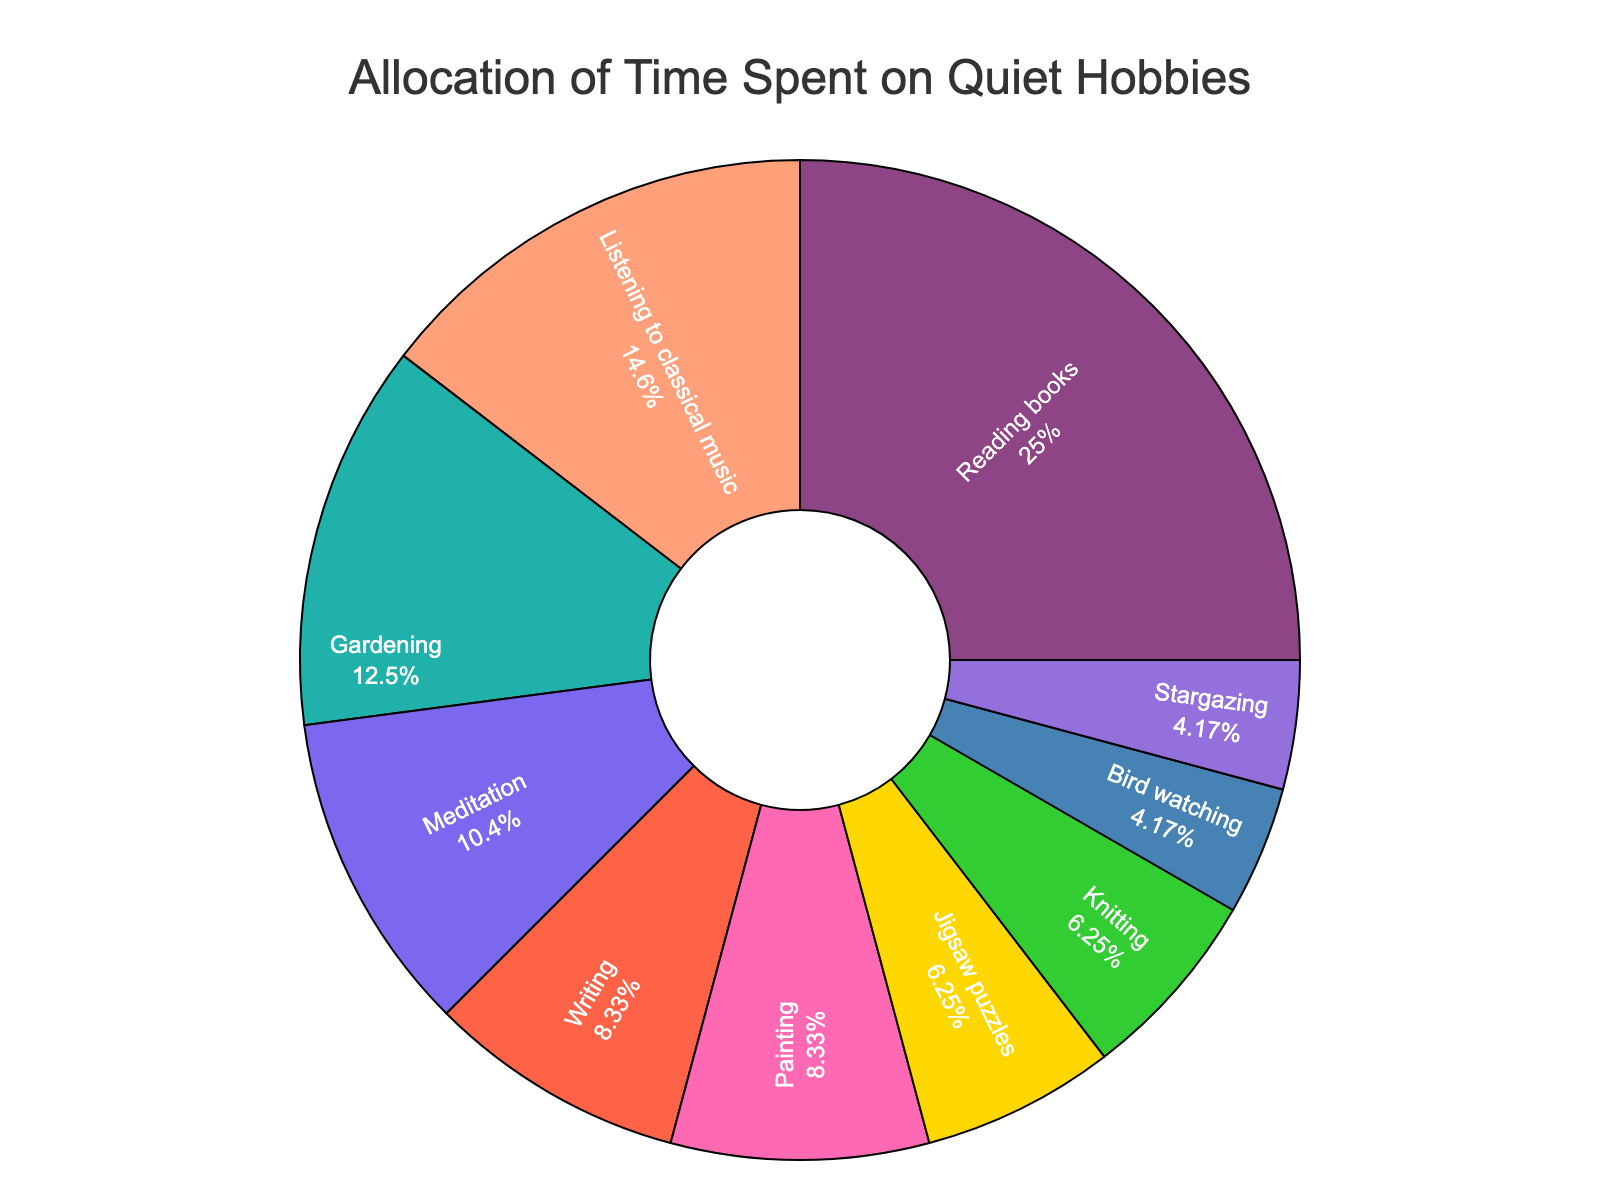What's the total amount of time spent on hobbies per week? The total amount of time is provided as an annotation below the pie chart. It states "Total: 48 hours per week."
Answer: 48 hours Which hobby takes up the most time? By looking at the pie chart segments, the largest section is labeled "Reading books" with 12 hours per week.
Answer: Reading books What percentage of the total time is spent on listening to classical music? According to the chart, "Listening to classical music" occupies a segment labeled with 7 hours. The percentage is also displayed as a value for each segment.
Answer: ~14.58% How much more time is spent on gardening compared to writing? The pie chart shows 6 hours for Gardening and 4 hours for Writing. Subtract the smaller value from the larger one: 6 - 4.
Answer: 2 hours Which hobby occupies the smallest portion of the chart? The smallest segment corresponds to "Bird watching" and "Stargazing" each with 2 hours.
Answer: Bird watching and Stargazing How many hours per week are spent on hobbies other than reading books? Subtract the hours spent on "Reading books" from the total hours: 48 - 12.
Answer: 36 hours Is the time spent on meditation greater than the time spent on painting? According to the chart, meditation is 5 hours and painting is 4 hours. 5 is greater than 4.
Answer: Yes What’s the combined percentage of the three hobbies with the least amount of time? Bird watching, Stargazing, and Jigsaw puzzles are the three hobbies with the least time (2, 2, and 3 hours). Sum the hours: 2 + 2 + 3 = 7 hours. Calculate the percentage (7/48 * 100).
Answer: ~14.58% Which hobby has an equal amount of time allocation as knitting? The chart shows that Jigsaw puzzles also have 3 hours per week, just like Knitting.
Answer: Jigsaw puzzles How much time is spent on artistic hobbies (painting, knitting, and writing) combined? Sum the hours spent on painting (4), knitting (3), and writing (4): 4 + 3 + 4.
Answer: 11 hours 